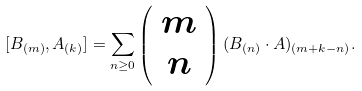Convert formula to latex. <formula><loc_0><loc_0><loc_500><loc_500>[ B _ { ( m ) } , A _ { ( k ) } ] = \sum _ { n \geq 0 } \left ( \begin{array} { c } m \\ n \end{array} \right ) ( B _ { ( n ) } \cdot A ) _ { ( m + k - n ) } .</formula> 